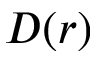<formula> <loc_0><loc_0><loc_500><loc_500>D ( r )</formula> 